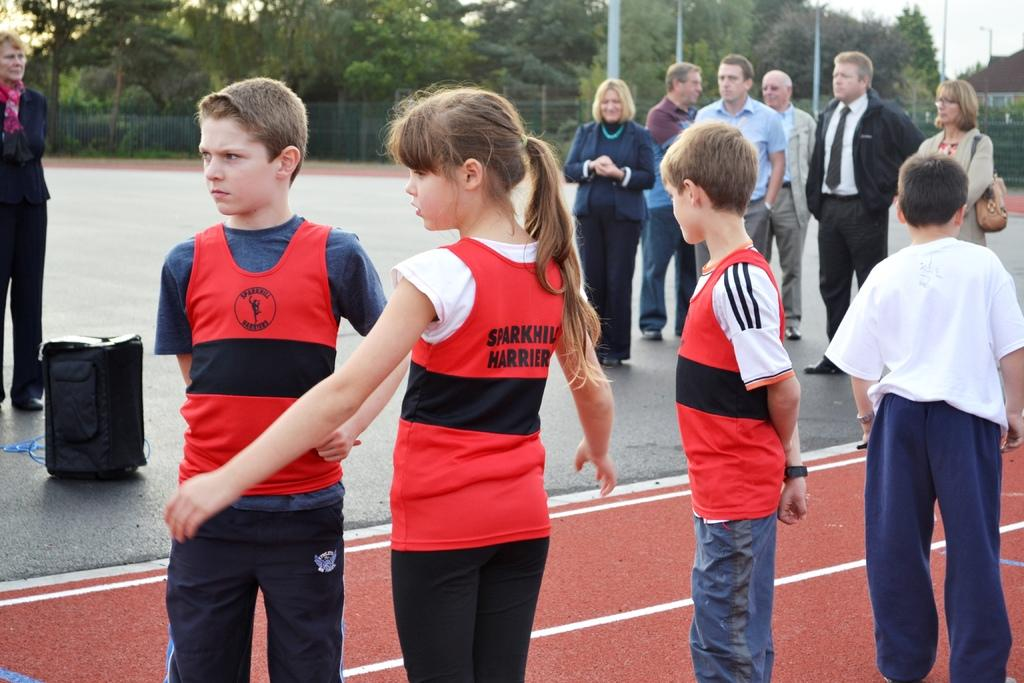What are the people in the image doing? The people in the image are standing on the road. What can be seen in the background of the image? In the background of the image, there are poles, fences, trees, and the sky. Can you describe the objects in the background? The background features poles, fences, and trees, and the sky is visible above them. What type of apparel is the bee wearing in the image? There is no bee present in the image, so it cannot be wearing any apparel. 